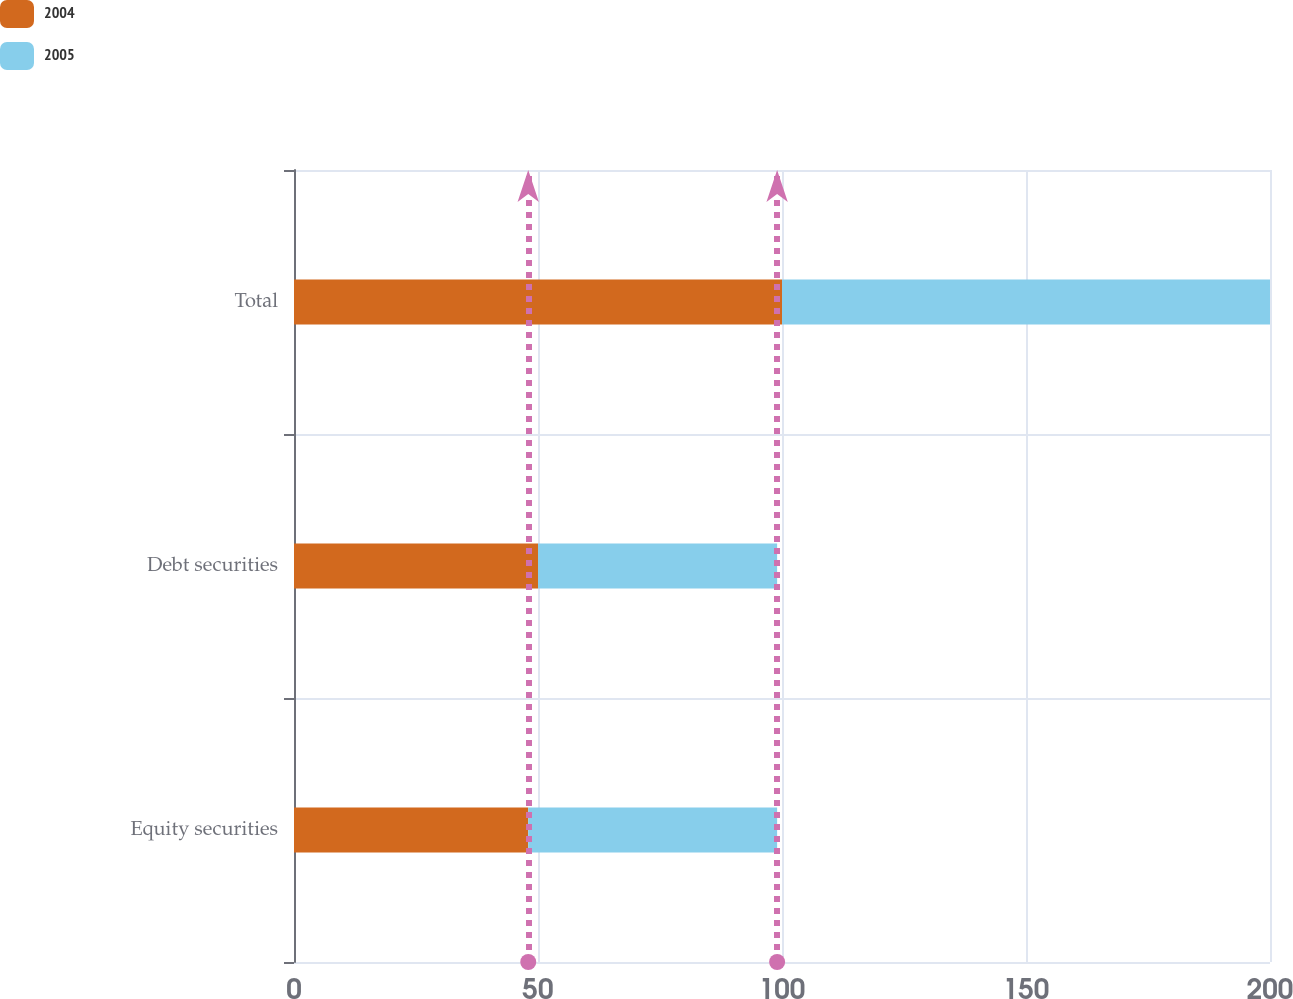Convert chart. <chart><loc_0><loc_0><loc_500><loc_500><stacked_bar_chart><ecel><fcel>Equity securities<fcel>Debt securities<fcel>Total<nl><fcel>2004<fcel>48<fcel>50<fcel>100<nl><fcel>2005<fcel>51<fcel>49<fcel>100<nl></chart> 